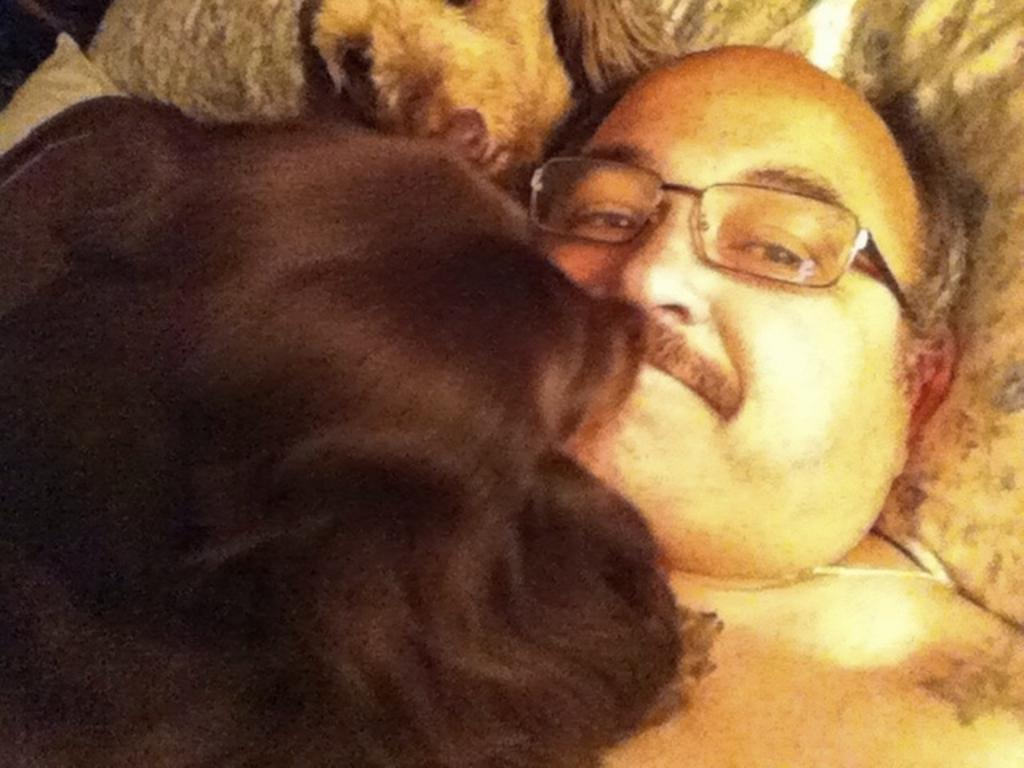What is the person in the image wearing on their face? The person in the image is wearing specs. Can you describe the animal on the left side of the image? Unfortunately, the facts provided do not mention any specific details about the animal. However, we can confirm that there is an animal present on the left side of the image. How does the person in the image blow a bubble with their knee? There is no mention of blowing bubbles or using knees in the provided facts. The image does not depict any such activity. 